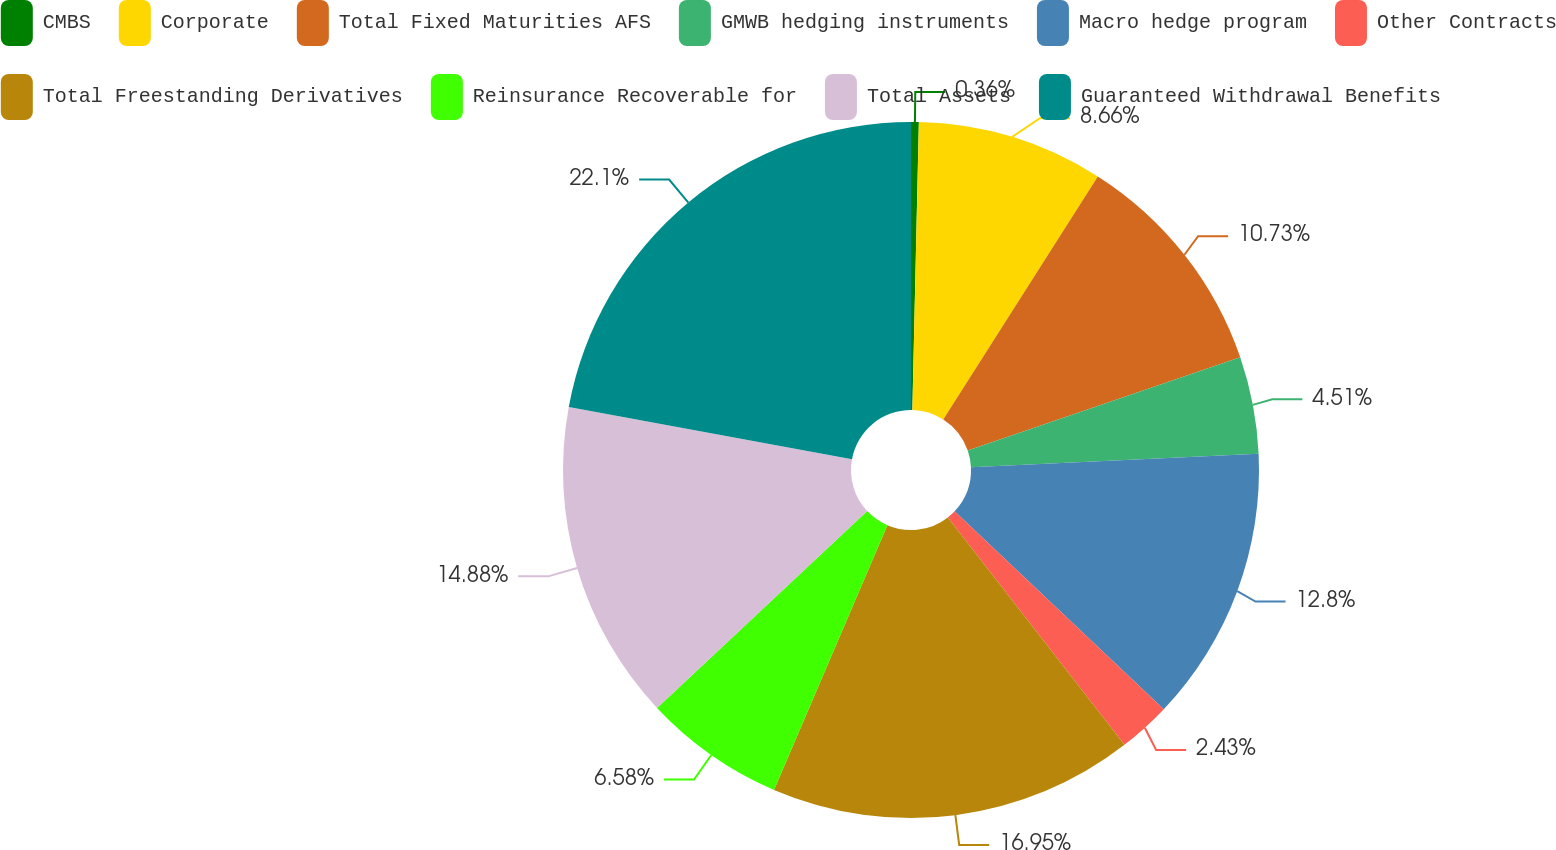<chart> <loc_0><loc_0><loc_500><loc_500><pie_chart><fcel>CMBS<fcel>Corporate<fcel>Total Fixed Maturities AFS<fcel>GMWB hedging instruments<fcel>Macro hedge program<fcel>Other Contracts<fcel>Total Freestanding Derivatives<fcel>Reinsurance Recoverable for<fcel>Total Assets<fcel>Guaranteed Withdrawal Benefits<nl><fcel>0.36%<fcel>8.66%<fcel>10.73%<fcel>4.51%<fcel>12.8%<fcel>2.43%<fcel>16.95%<fcel>6.58%<fcel>14.88%<fcel>22.1%<nl></chart> 